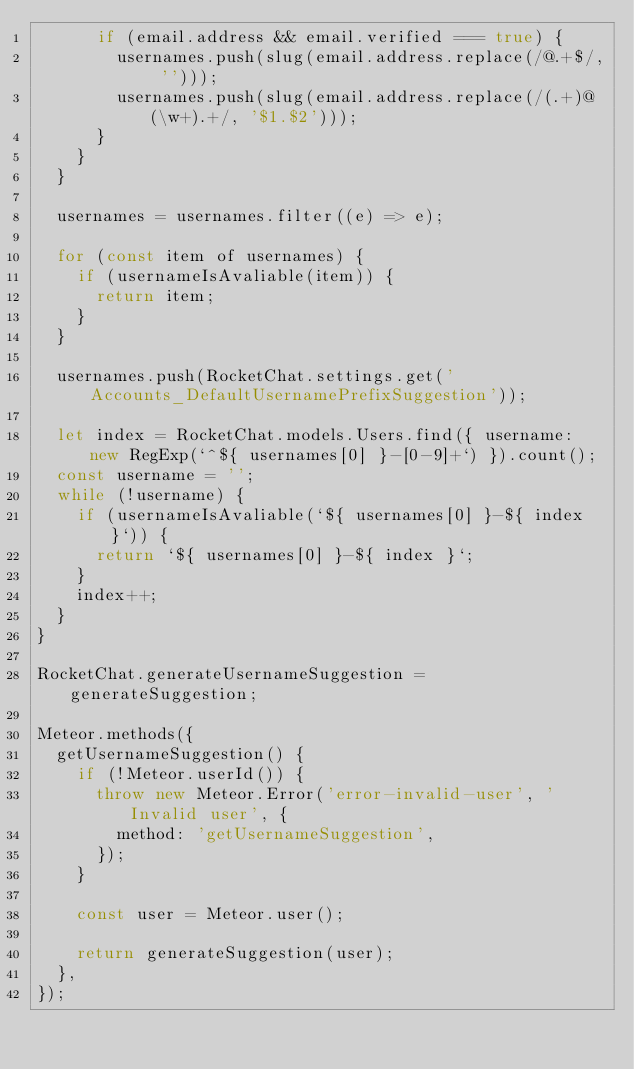<code> <loc_0><loc_0><loc_500><loc_500><_JavaScript_>			if (email.address && email.verified === true) {
				usernames.push(slug(email.address.replace(/@.+$/, '')));
				usernames.push(slug(email.address.replace(/(.+)@(\w+).+/, '$1.$2')));
			}
		}
	}

	usernames = usernames.filter((e) => e);

	for (const item of usernames) {
		if (usernameIsAvaliable(item)) {
			return item;
		}
	}

	usernames.push(RocketChat.settings.get('Accounts_DefaultUsernamePrefixSuggestion'));

	let index = RocketChat.models.Users.find({ username: new RegExp(`^${ usernames[0] }-[0-9]+`) }).count();
	const username = '';
	while (!username) {
		if (usernameIsAvaliable(`${ usernames[0] }-${ index }`)) {
			return `${ usernames[0] }-${ index }`;
		}
		index++;
	}
}

RocketChat.generateUsernameSuggestion = generateSuggestion;

Meteor.methods({
	getUsernameSuggestion() {
		if (!Meteor.userId()) {
			throw new Meteor.Error('error-invalid-user', 'Invalid user', {
				method: 'getUsernameSuggestion',
			});
		}

		const user = Meteor.user();

		return generateSuggestion(user);
	},
});
</code> 